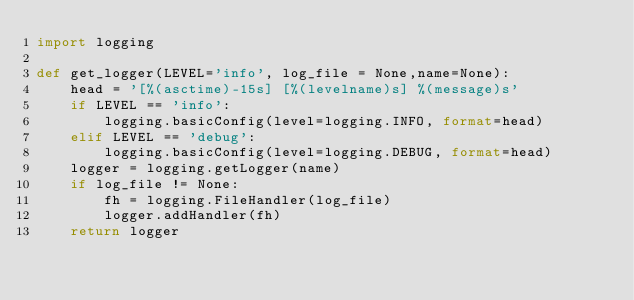<code> <loc_0><loc_0><loc_500><loc_500><_Python_>import logging

def get_logger(LEVEL='info', log_file = None,name=None):
    head = '[%(asctime)-15s] [%(levelname)s] %(message)s'
    if LEVEL == 'info':
        logging.basicConfig(level=logging.INFO, format=head)
    elif LEVEL == 'debug':
        logging.basicConfig(level=logging.DEBUG, format=head)
    logger = logging.getLogger(name)
    if log_file != None:
        fh = logging.FileHandler(log_file)
        logger.addHandler(fh)
    return logger
</code> 